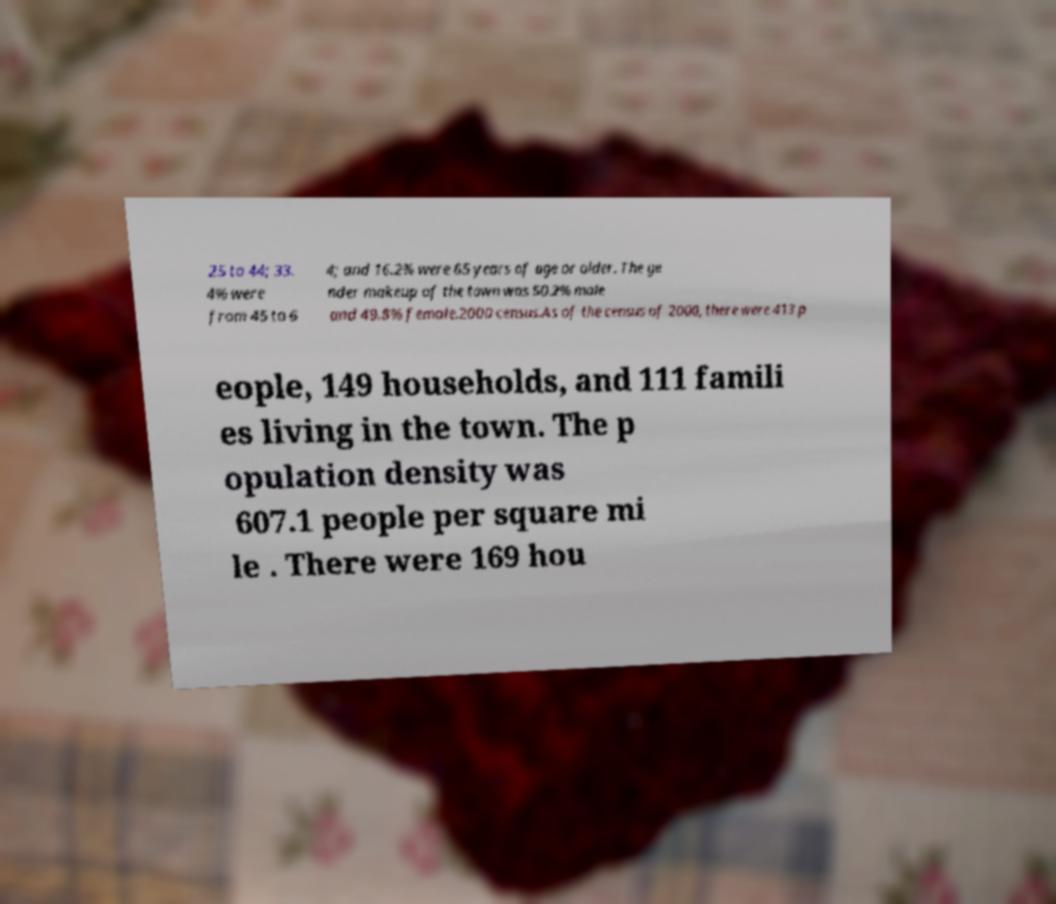Please read and relay the text visible in this image. What does it say? 25 to 44; 33. 4% were from 45 to 6 4; and 16.2% were 65 years of age or older. The ge nder makeup of the town was 50.2% male and 49.8% female.2000 census.As of the census of 2000, there were 413 p eople, 149 households, and 111 famili es living in the town. The p opulation density was 607.1 people per square mi le . There were 169 hou 